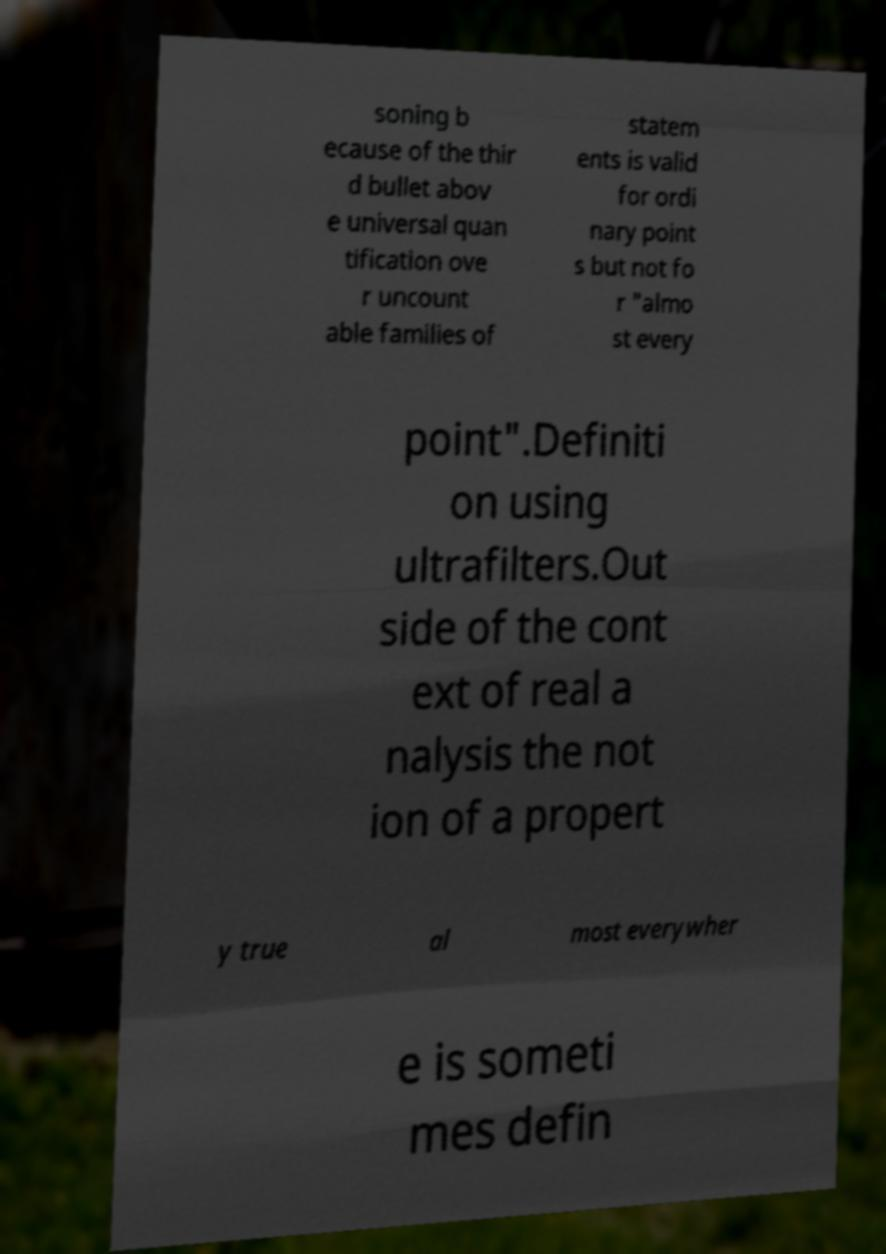Could you assist in decoding the text presented in this image and type it out clearly? soning b ecause of the thir d bullet abov e universal quan tification ove r uncount able families of statem ents is valid for ordi nary point s but not fo r "almo st every point".Definiti on using ultrafilters.Out side of the cont ext of real a nalysis the not ion of a propert y true al most everywher e is someti mes defin 